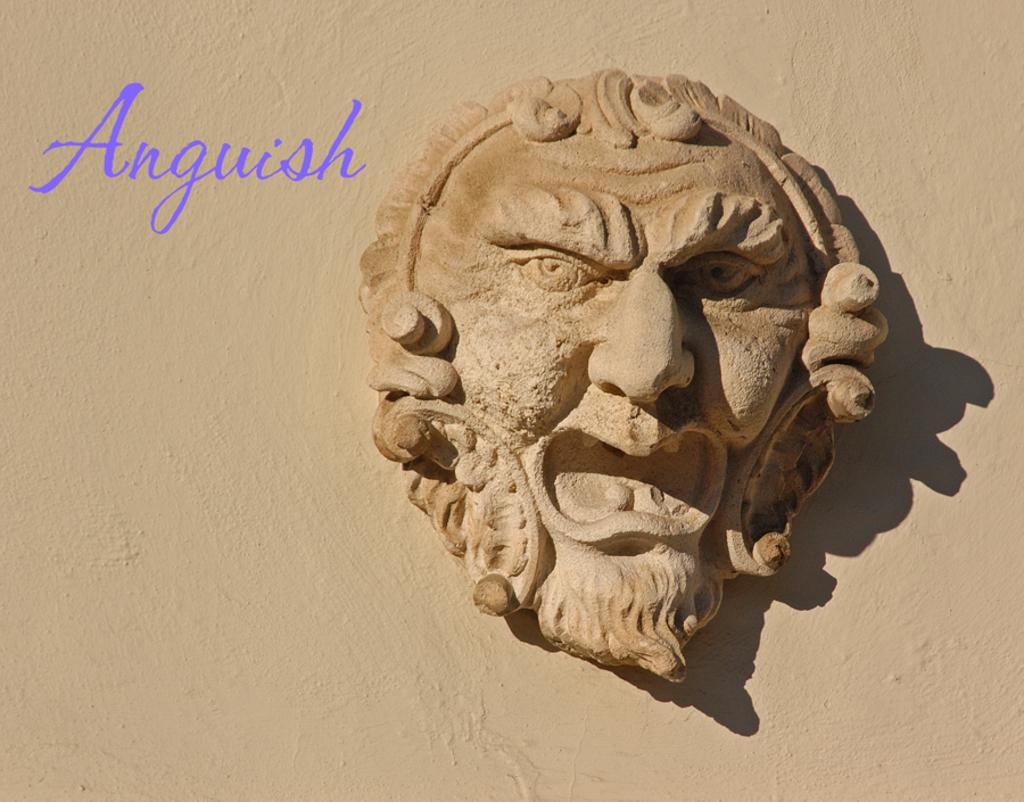What is the main subject of the image? There is a sculpture in the image. How is the sculpture positioned in relation to the wall? The sculpture is attached to a wall. Can you describe any additional features of the image? There is a watermark visible in the image. How many pizzas are being sold at the store in the image? There is no store or pizzas present in the image; it features a sculpture attached to a wall with a visible watermark. What type of trees can be seen in the image? There are no trees present in the image. 